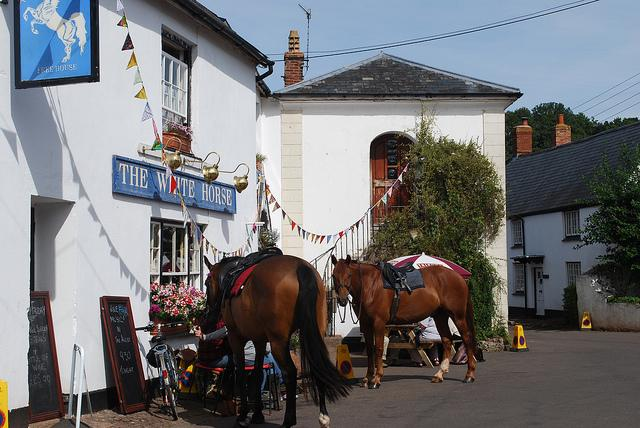What type of movie would this scene appear in? western 